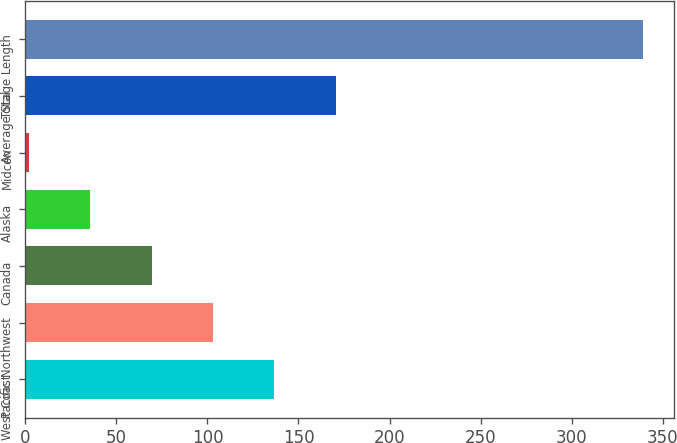<chart> <loc_0><loc_0><loc_500><loc_500><bar_chart><fcel>West Coast<fcel>Pacific Northwest<fcel>Canada<fcel>Alaska<fcel>Midcon<fcel>Total<fcel>Average Stage Length<nl><fcel>136.8<fcel>103.1<fcel>69.4<fcel>35.7<fcel>2<fcel>170.5<fcel>339<nl></chart> 